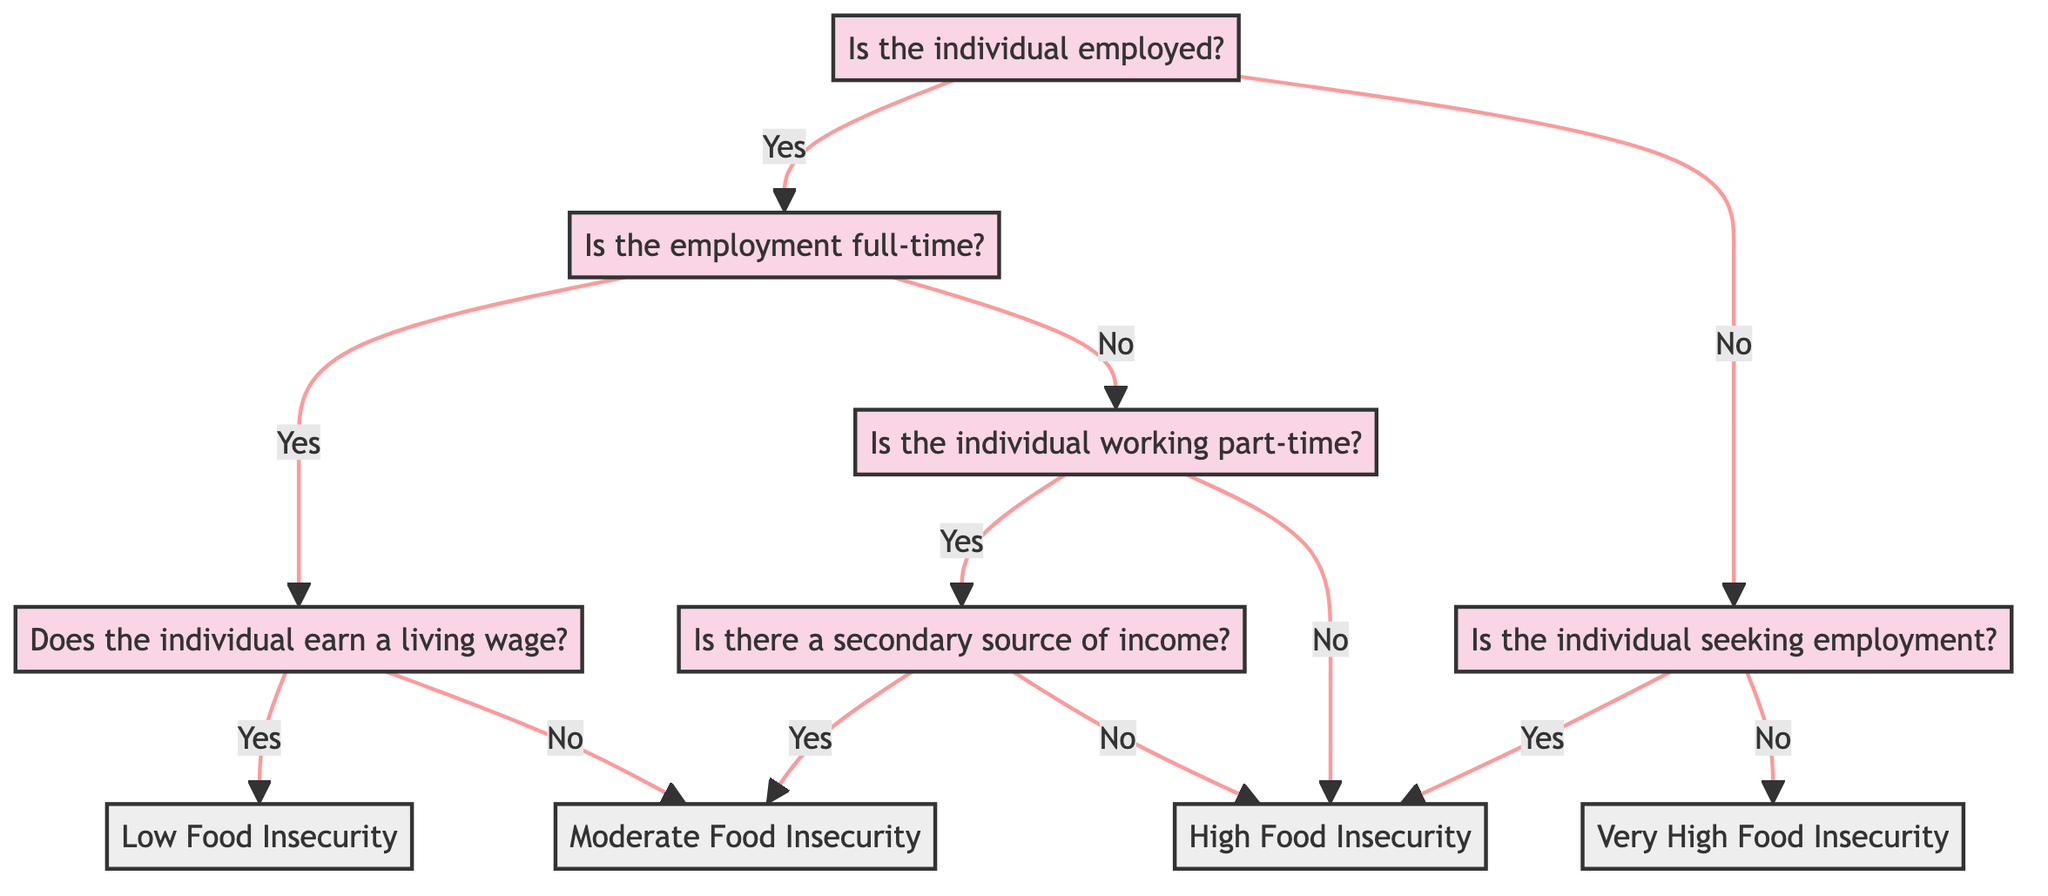Is the first question in the diagram about employment status? The diagram begins with the root question, which asks if the individual is employed, making it the first question.
Answer: Yes What is the outcome if the individual is employed full-time and earns a living wage? Following the path from the root question, if the individual is employed and their employment is full-time along with earning a living wage, the corresponding outcome is low food insecurity.
Answer: Low Food Insecurity How many outcomes are there in the decision tree? The outcomes at the end of the decision tree branches are identified as distinct results, which are low food insecurity, moderate food insecurity, high food insecurity, and very high food insecurity, totaling four outcomes.
Answer: 4 What indicates high food insecurity in the decision tree? The determination for high food insecurity occurs when the individual is either not employed and seeking employment or if they are employed in part-time work without a secondary source of income.
Answer: Seeking employment or part-time without secondary income If someone is not employed and not seeking employment, what is their food insecurity outcome? In the decision tree, the path indicates that if an individual is not employed and also not seeking employment, the resulting outcome is very high food insecurity.
Answer: Very High Food Insecurity What happens when an individual works part-time without a secondary source of income? The decision tree specifies that if a person works part-time and does not have a secondary income, they will face high food insecurity, establishing a direct correlation between this employment status and food insecurity level.
Answer: High Food Insecurity Is moderate food insecurity an outcome of both part-time employment with a secondary income and full-time employment without a living wage? The diagram shows that moderate food insecurity arises under two conditions: if an individual is part-time with a secondary source of income or if they are employed full-time but do not earn a living wage.
Answer: Yes What is the outcome for someone working part-time with a secondary source of income? According to the decision tree flow, when a person works part-time and possesses a secondary income, the outcome identified is moderate food insecurity.
Answer: Moderate Food Insecurity 